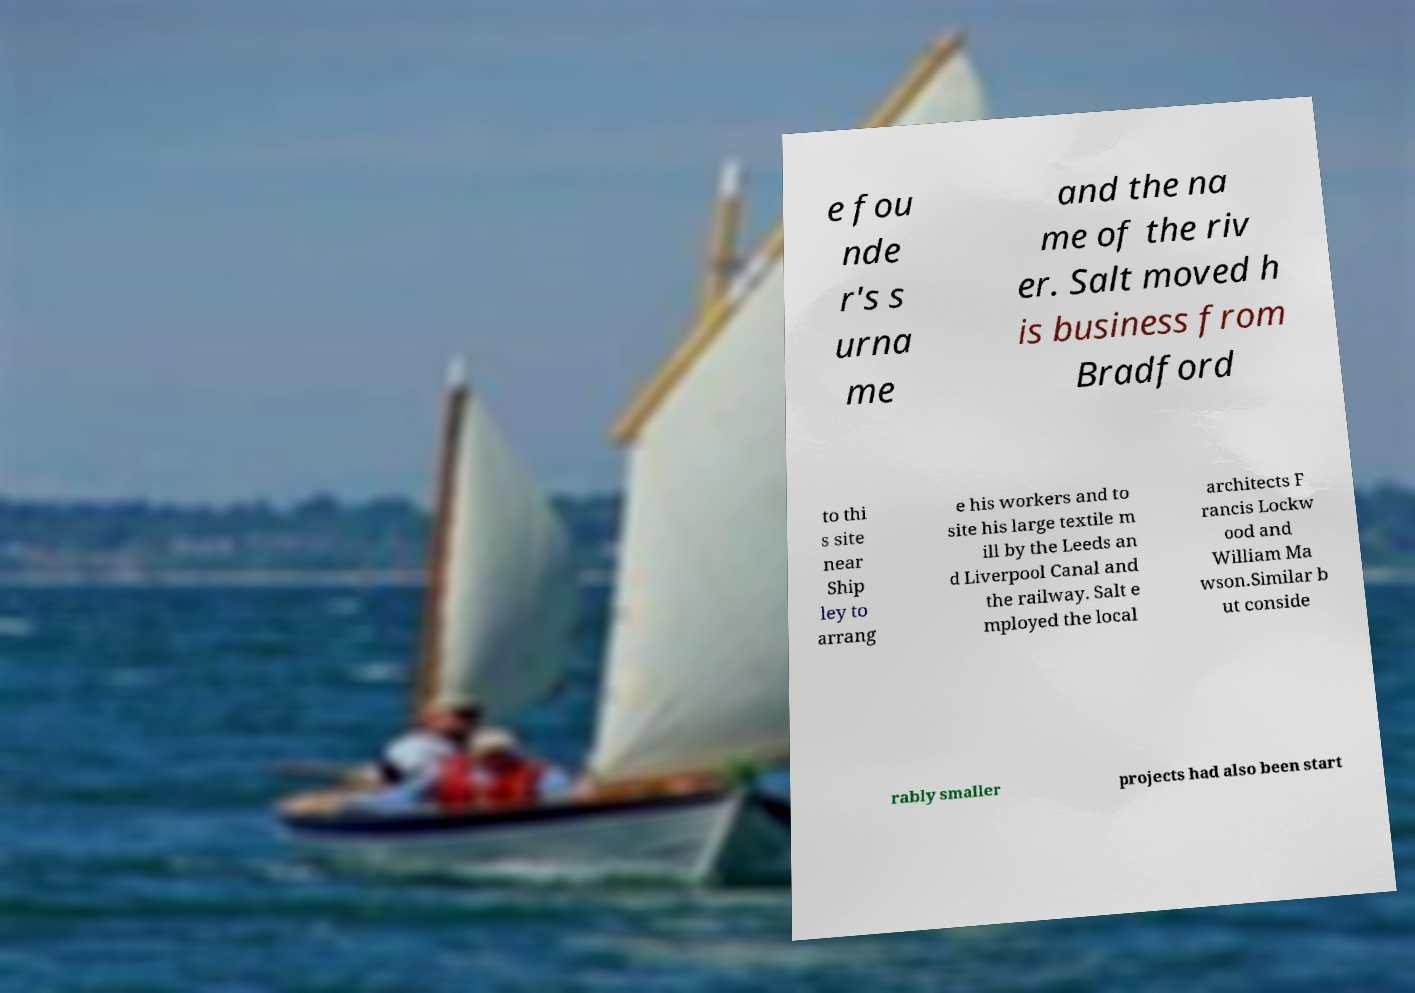There's text embedded in this image that I need extracted. Can you transcribe it verbatim? e fou nde r's s urna me and the na me of the riv er. Salt moved h is business from Bradford to thi s site near Ship ley to arrang e his workers and to site his large textile m ill by the Leeds an d Liverpool Canal and the railway. Salt e mployed the local architects F rancis Lockw ood and William Ma wson.Similar b ut conside rably smaller projects had also been start 